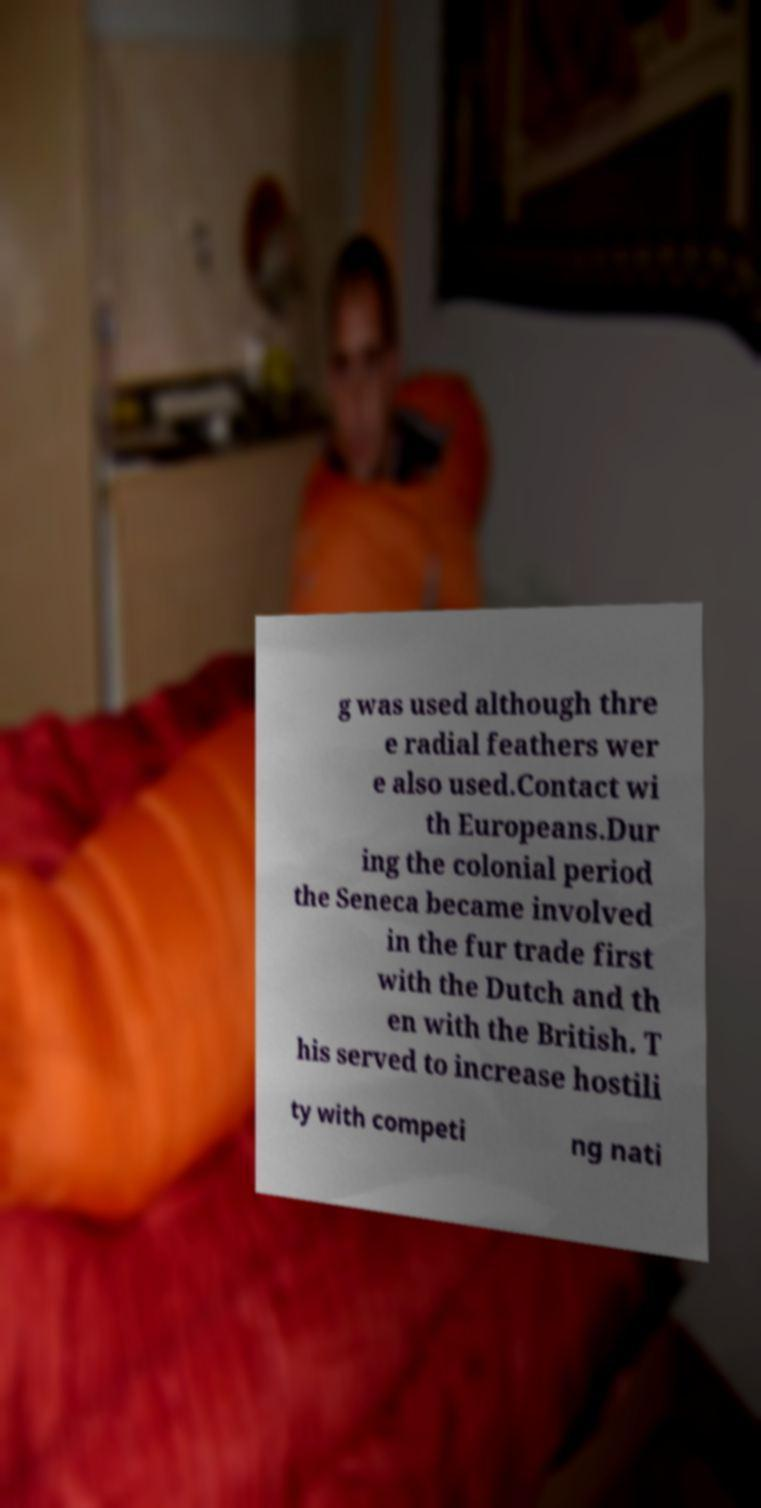Can you accurately transcribe the text from the provided image for me? g was used although thre e radial feathers wer e also used.Contact wi th Europeans.Dur ing the colonial period the Seneca became involved in the fur trade first with the Dutch and th en with the British. T his served to increase hostili ty with competi ng nati 